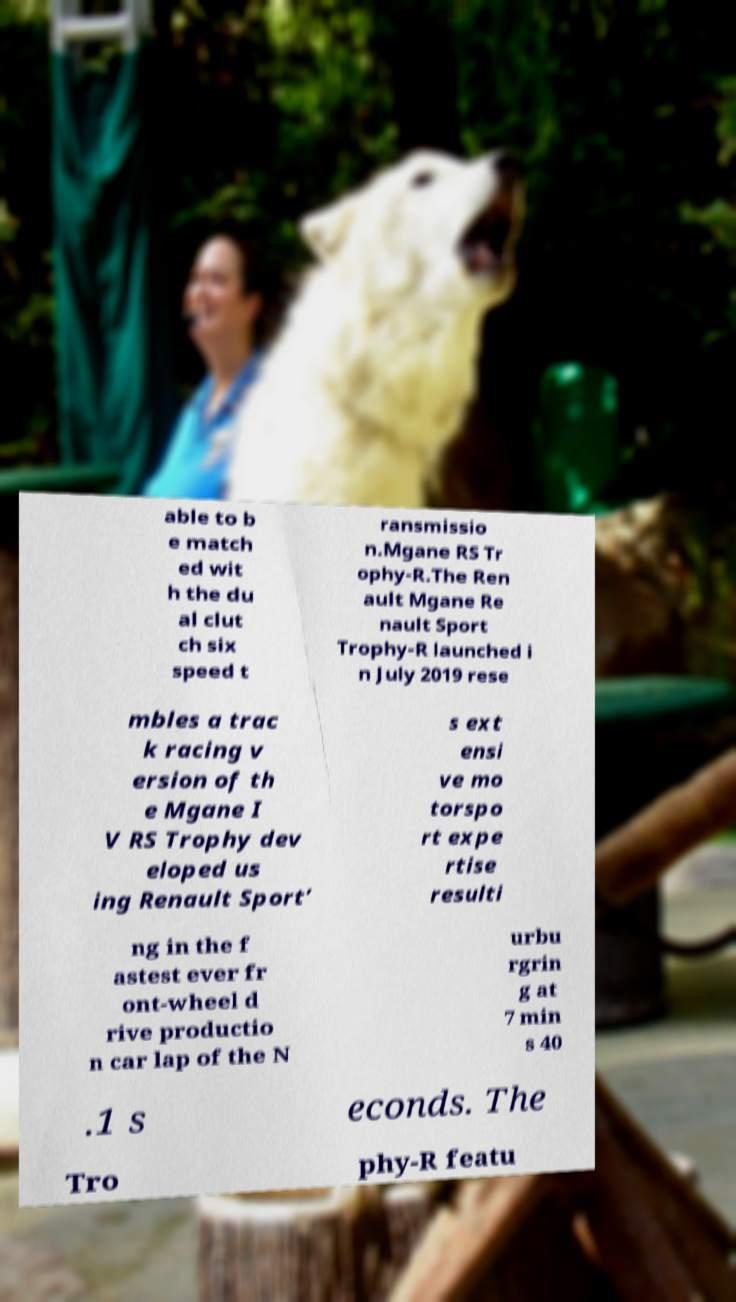I need the written content from this picture converted into text. Can you do that? able to b e match ed wit h the du al clut ch six speed t ransmissio n.Mgane RS Tr ophy-R.The Ren ault Mgane Re nault Sport Trophy-R launched i n July 2019 rese mbles a trac k racing v ersion of th e Mgane I V RS Trophy dev eloped us ing Renault Sport’ s ext ensi ve mo torspo rt expe rtise resulti ng in the f astest ever fr ont-wheel d rive productio n car lap of the N urbu rgrin g at 7 min s 40 .1 s econds. The Tro phy-R featu 